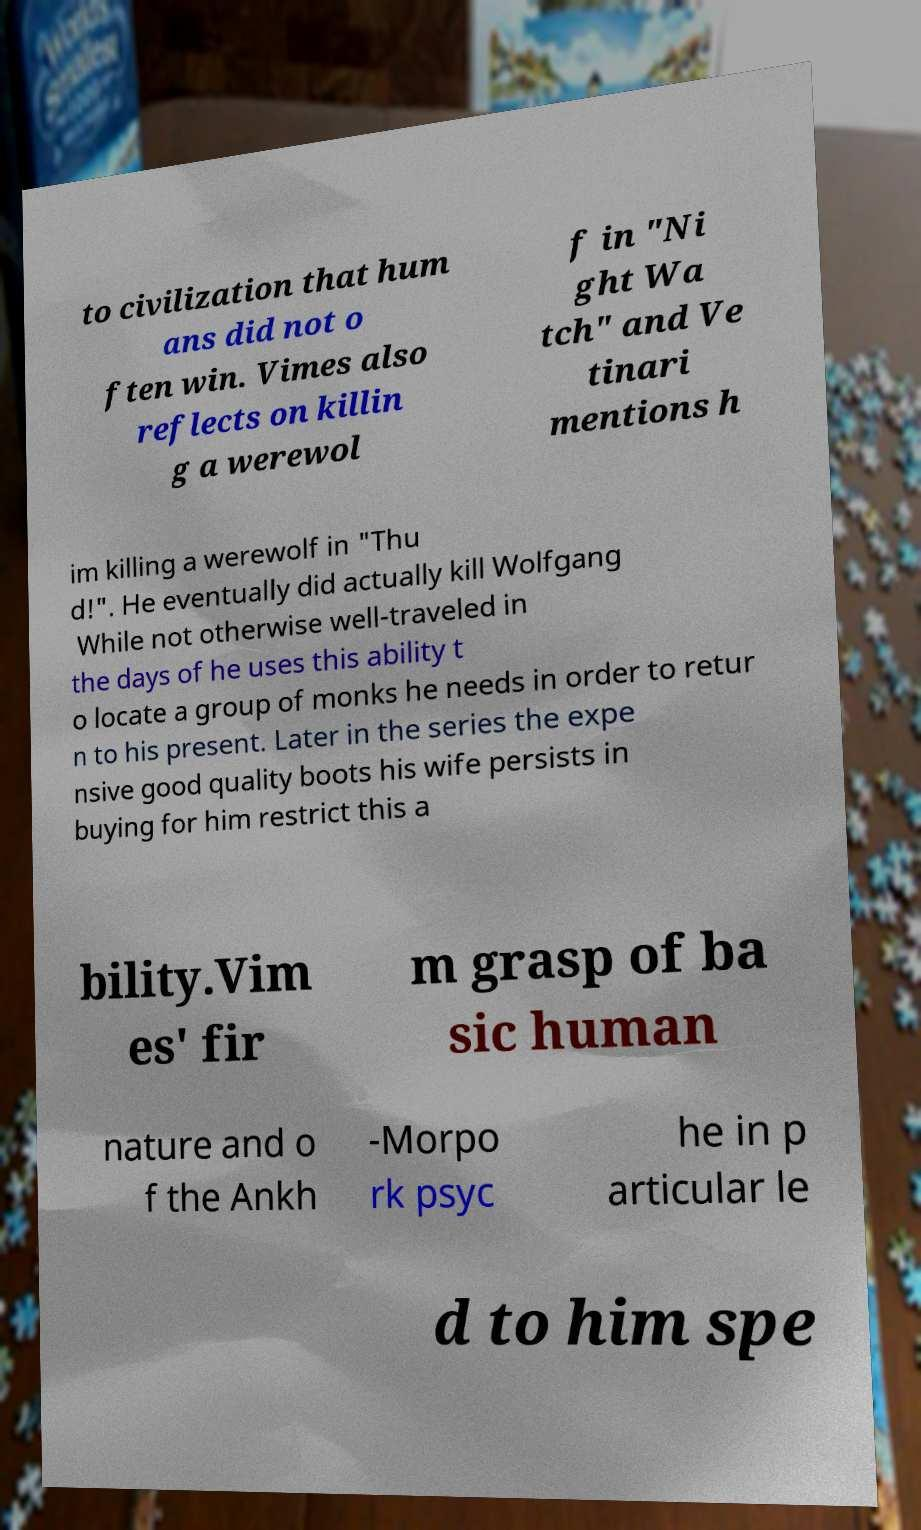For documentation purposes, I need the text within this image transcribed. Could you provide that? to civilization that hum ans did not o ften win. Vimes also reflects on killin g a werewol f in "Ni ght Wa tch" and Ve tinari mentions h im killing a werewolf in "Thu d!". He eventually did actually kill Wolfgang While not otherwise well-traveled in the days of he uses this ability t o locate a group of monks he needs in order to retur n to his present. Later in the series the expe nsive good quality boots his wife persists in buying for him restrict this a bility.Vim es' fir m grasp of ba sic human nature and o f the Ankh -Morpo rk psyc he in p articular le d to him spe 